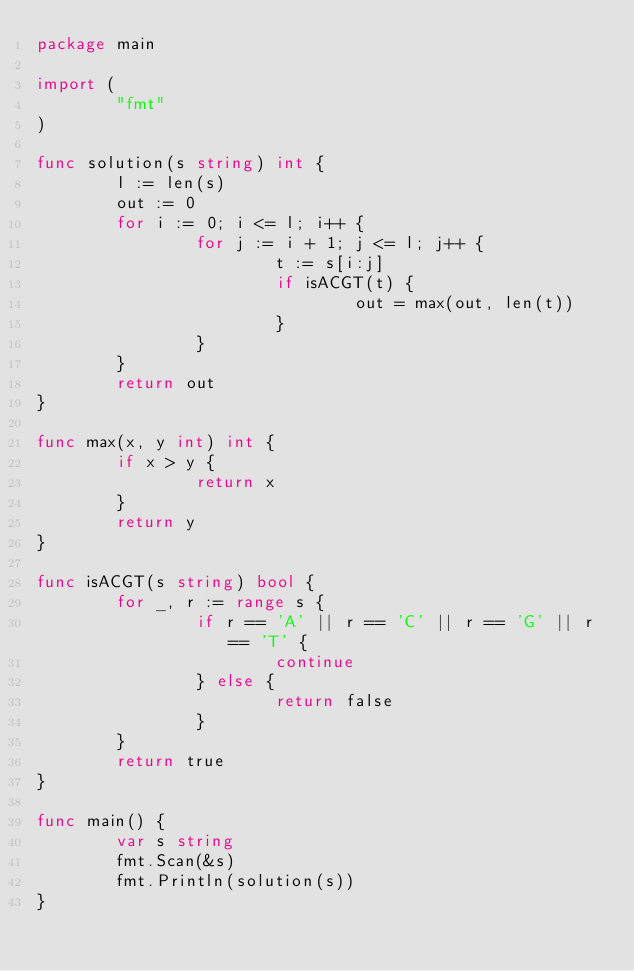Convert code to text. <code><loc_0><loc_0><loc_500><loc_500><_Go_>package main

import (
        "fmt"
)

func solution(s string) int {
        l := len(s)
        out := 0
        for i := 0; i <= l; i++ {
                for j := i + 1; j <= l; j++ {
                        t := s[i:j]
                        if isACGT(t) {
                                out = max(out, len(t))
                        }
                }
        }
        return out
}

func max(x, y int) int {
        if x > y {
                return x
        }
        return y
}

func isACGT(s string) bool {
        for _, r := range s {
                if r == 'A' || r == 'C' || r == 'G' || r == 'T' {
                        continue
                } else {
                        return false
                }
        }
        return true
}

func main() {
        var s string
        fmt.Scan(&s)
        fmt.Println(solution(s))
}
</code> 